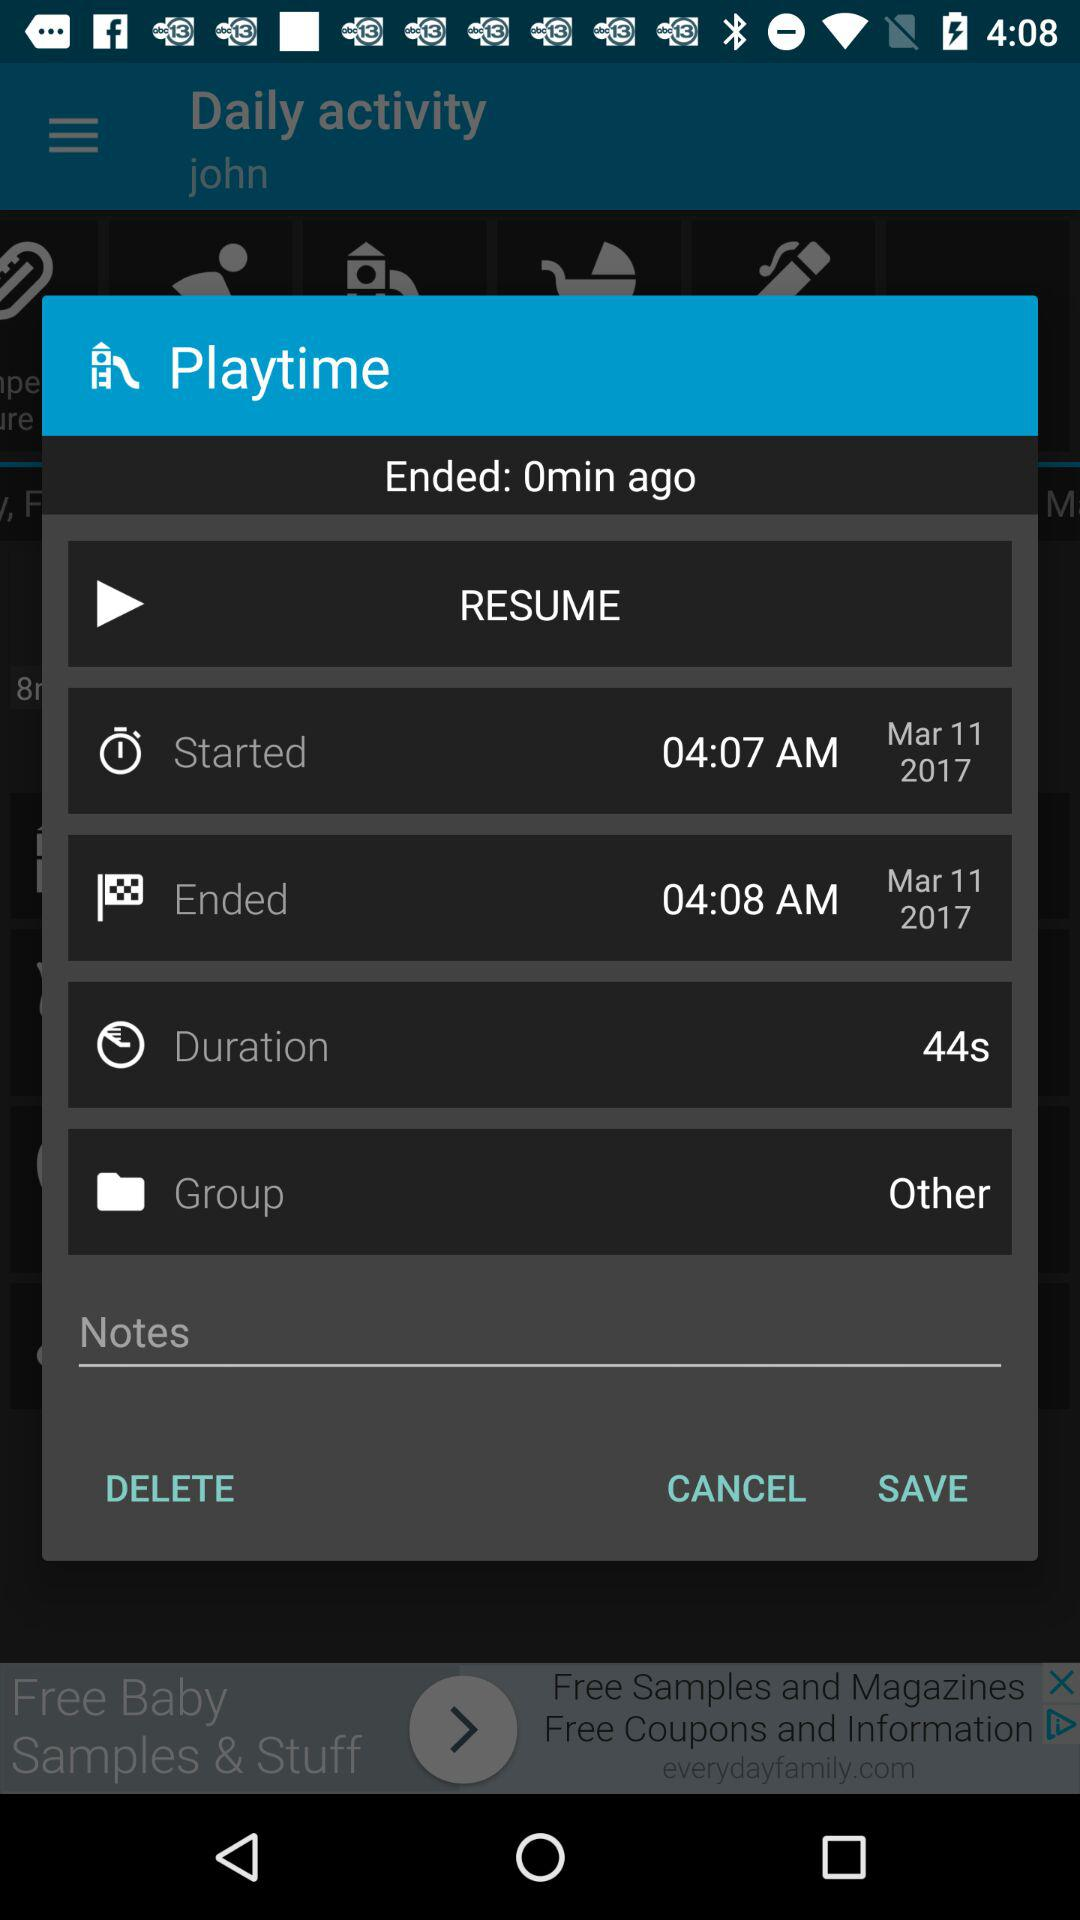What is the date? The date is March 11, 2017. 